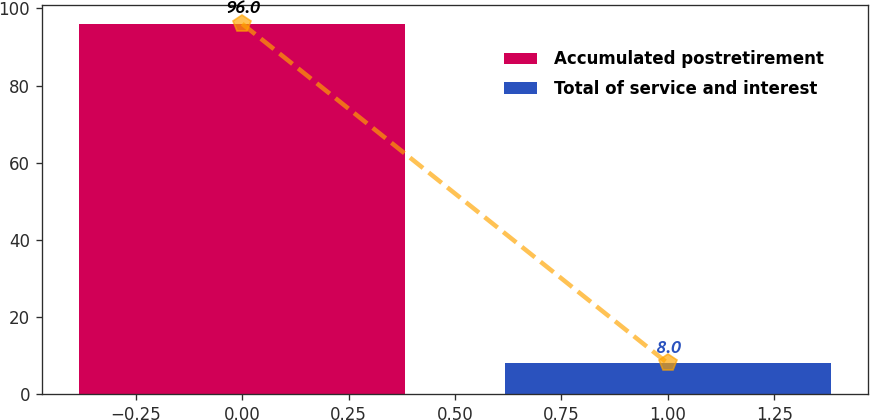Convert chart to OTSL. <chart><loc_0><loc_0><loc_500><loc_500><bar_chart><fcel>Accumulated postretirement<fcel>Total of service and interest<nl><fcel>96<fcel>8<nl></chart> 